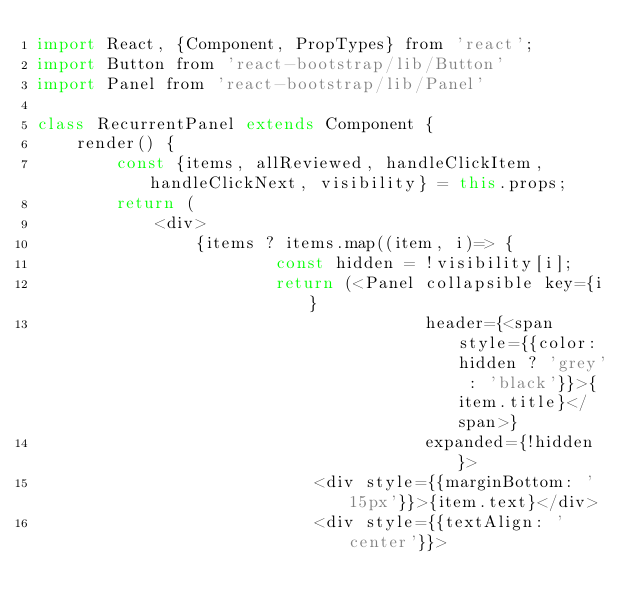Convert code to text. <code><loc_0><loc_0><loc_500><loc_500><_JavaScript_>import React, {Component, PropTypes} from 'react';
import Button from 'react-bootstrap/lib/Button'
import Panel from 'react-bootstrap/lib/Panel'

class RecurrentPanel extends Component {
    render() {
        const {items, allReviewed, handleClickItem, handleClickNext, visibility} = this.props;
        return (
            <div>
                {items ? items.map((item, i)=> {
                        const hidden = !visibility[i];
                        return (<Panel collapsible key={i}
                                       header={<span style={{color: hidden ? 'grey' : 'black'}}>{item.title}</span>}
                                       expanded={!hidden}>
                            <div style={{marginBottom: '15px'}}>{item.text}</div>
                            <div style={{textAlign: 'center'}}></code> 